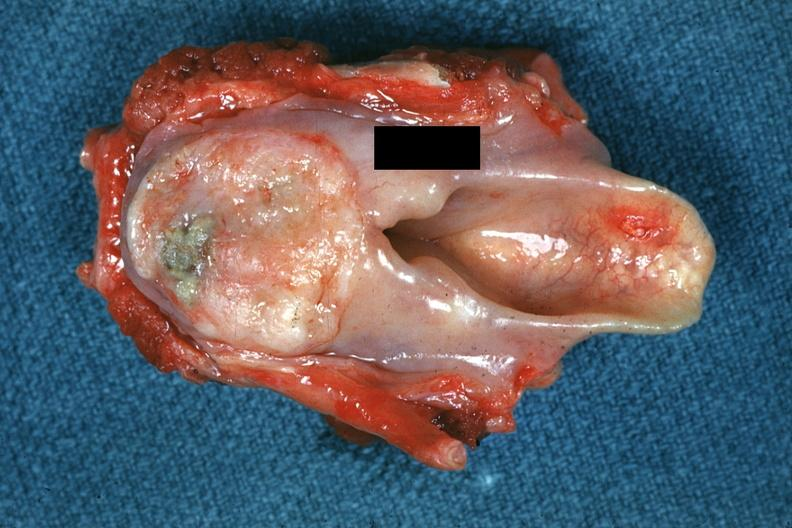s squamous cell carcinoma present?
Answer the question using a single word or phrase. Yes 